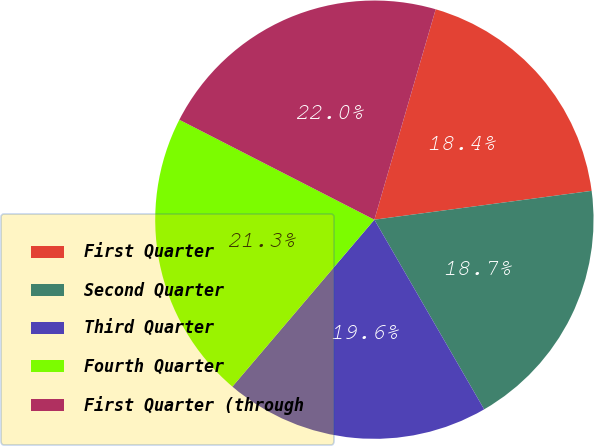Convert chart. <chart><loc_0><loc_0><loc_500><loc_500><pie_chart><fcel>First Quarter<fcel>Second Quarter<fcel>Third Quarter<fcel>Fourth Quarter<fcel>First Quarter (through<nl><fcel>18.39%<fcel>18.75%<fcel>19.57%<fcel>21.32%<fcel>21.98%<nl></chart> 